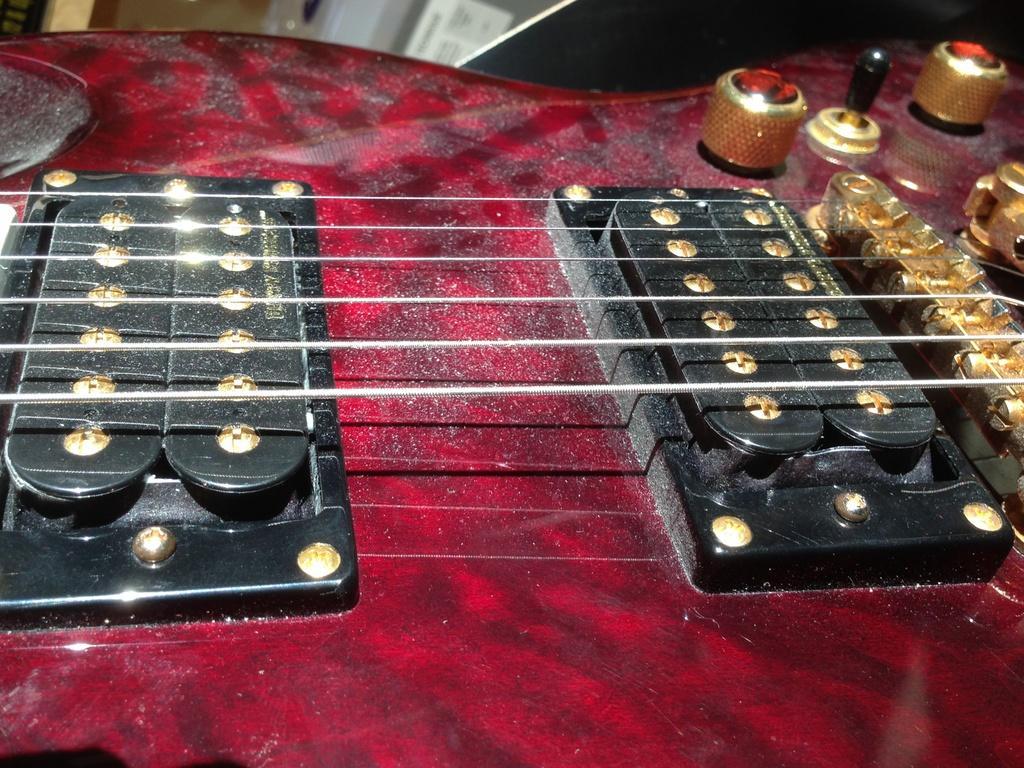Can you describe this image briefly? In this image I can see a part of a guitar. At the top there are some other objects. 